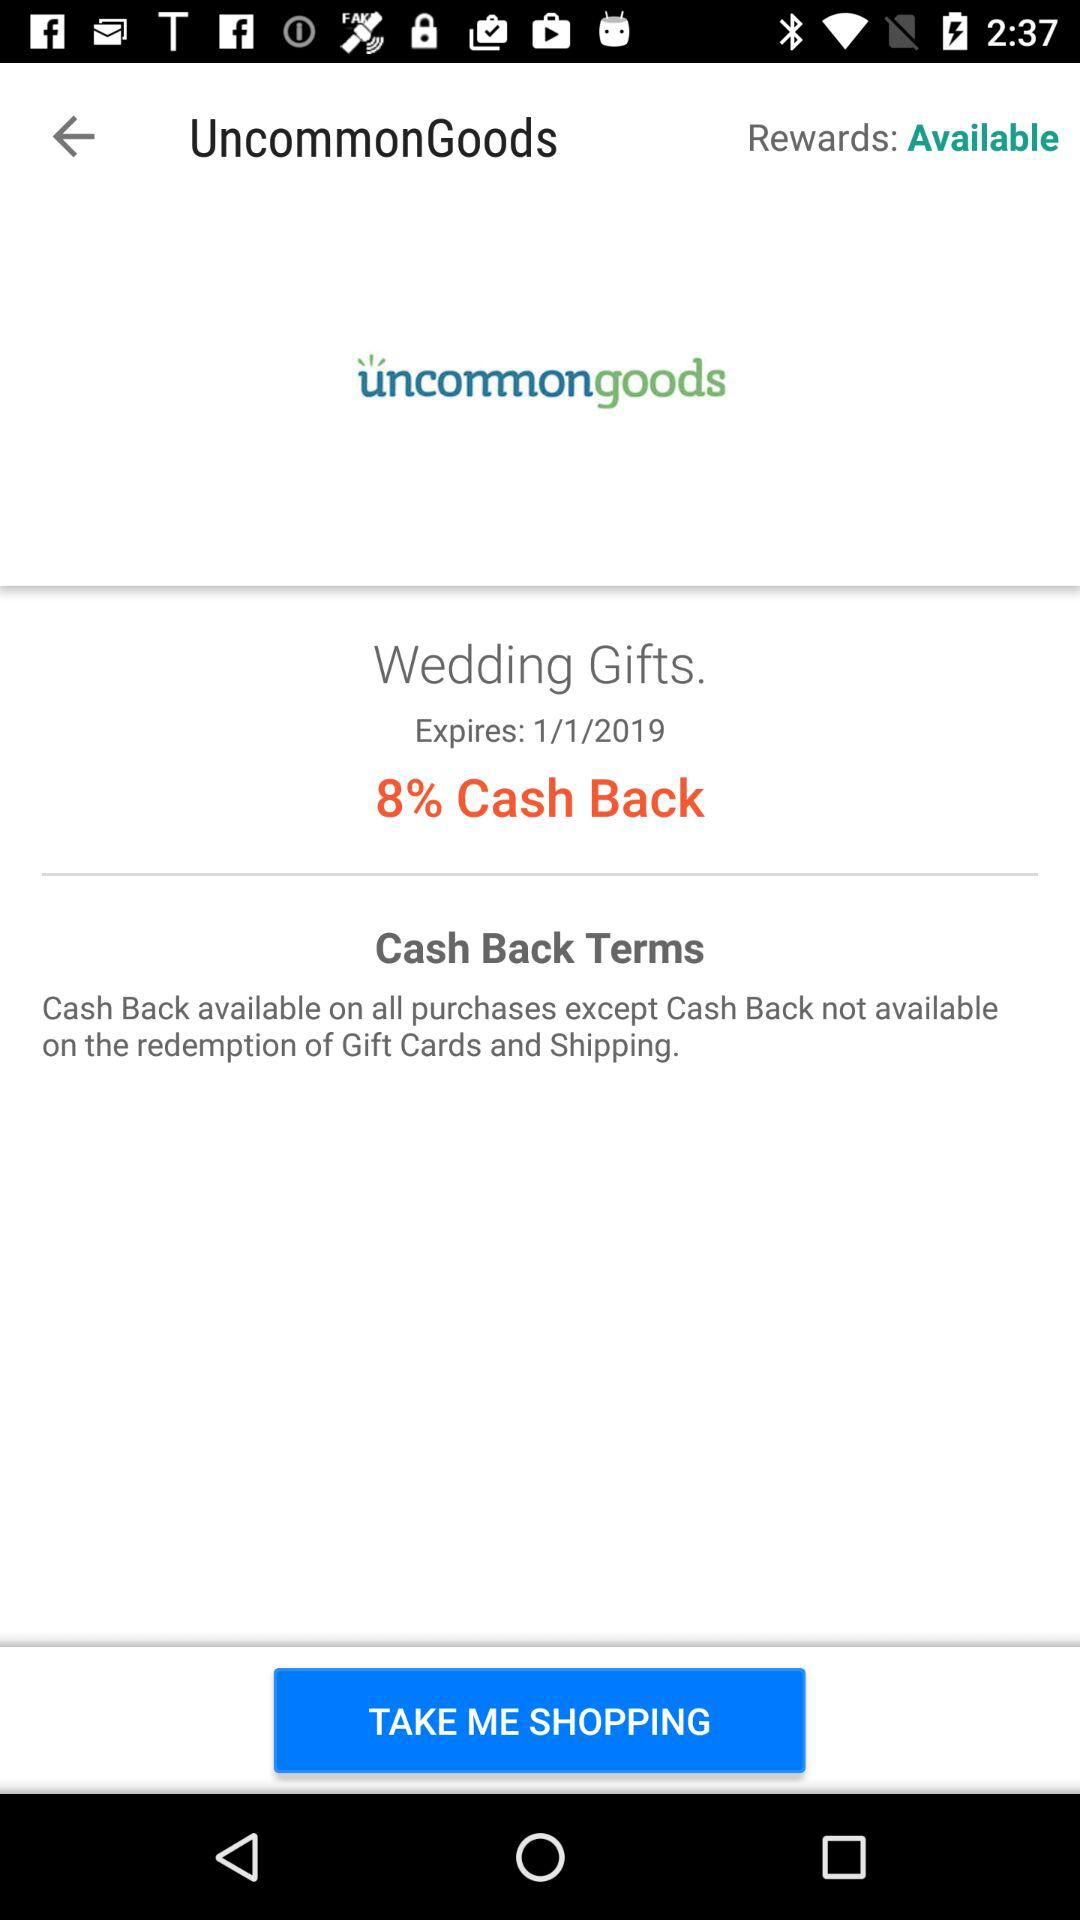What is the expiry date for wedding gifts with the 8% cashback? The expiry date for wedding gifts is January 1, 2019. 